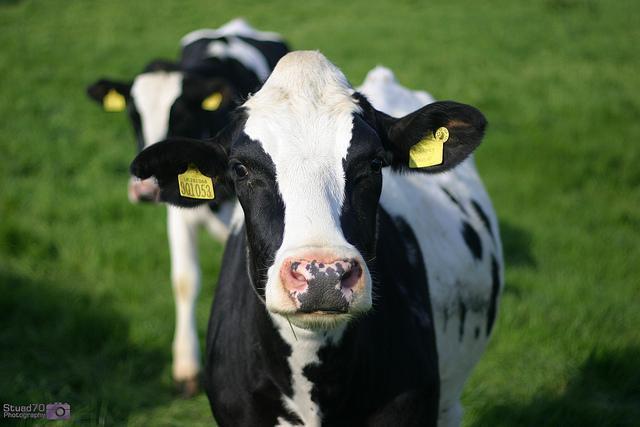How many cows are visible?
Give a very brief answer. 2. How many people are there?
Give a very brief answer. 0. 